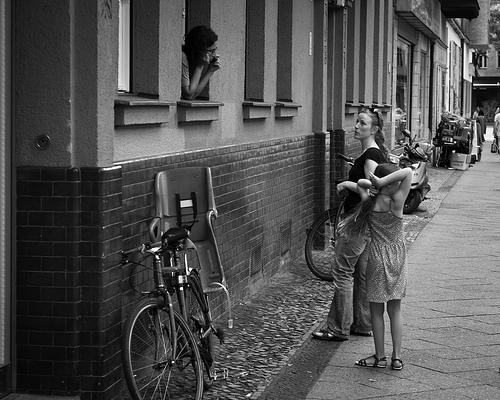Question: where was the photo taken?
Choices:
A. Restaurant.
B. Street.
C. Hospital.
D. School.
Answer with the letter. Answer: B Question: what is against the house?
Choices:
A. Bike.
B. A hose.
C. A skateboard.
D. A milk crate.
Answer with the letter. Answer: A Question: what style is the photo?
Choices:
A. Sepia.
B. Black and white.
C. Anime.
D. Color.
Answer with the letter. Answer: B Question: who took the photo?
Choices:
A. The photographer.
B. Tourist.
C. The man on the stairs.
D. The woman on the bus.
Answer with the letter. Answer: B 